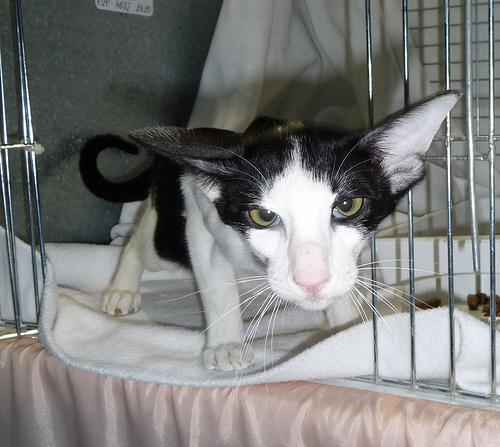Provide a concise description of the central focus in the image. A black and white cat stands up in a metal cage with a blanket, displaying its distinct eyes, ears, and nose. Imagine a short story that includes the main element of the image. Once upon a time, a black and white cat was found in a cage with a cozy blanket. The feline stood up with its bright eyes, pink nose, and furry ears, hoping to be noticed and rescued by a kind stranger. Mention the main components you observe in the image. A caged black and white cat, noticeable eyes, pink nose, furry ears, cage, and a blanket. What might be the subject's perspective in the image? I'm a black and white cat in a metal cage, standing up, and seeking attention with my sparkling eyes and remarkable features. Compose a short poem describing the main scene in the image. A cozy blanket, and freedom confined. Detail the particular image components that stand out. Black and white cat standing, cage, blanket, display of eyes, pink nose, and perky ears. Create a brief narrative describing the primary figure and activity in the image. A curious white and black cat is standing up in a metal cage, with its striking eyes, pink nose, and perky ears, catching everyone's attention. Construct a brief advertisement showcasing the image's main feature. Meet the adorable black and white feline with enchanting eyes, a pink nose, and fuzzy ears! This charming cat, standing up in a cage, is waiting for you to become its forever friend. Adopt today! List the most apparent descriptive information in the image. Cage, black and white cat, standing position, blanket, eyes, pink nose, furry ears. Write a newspaper headline describing the image. Captivating Black and White Feline Caught in Cage Awaits Rescue 